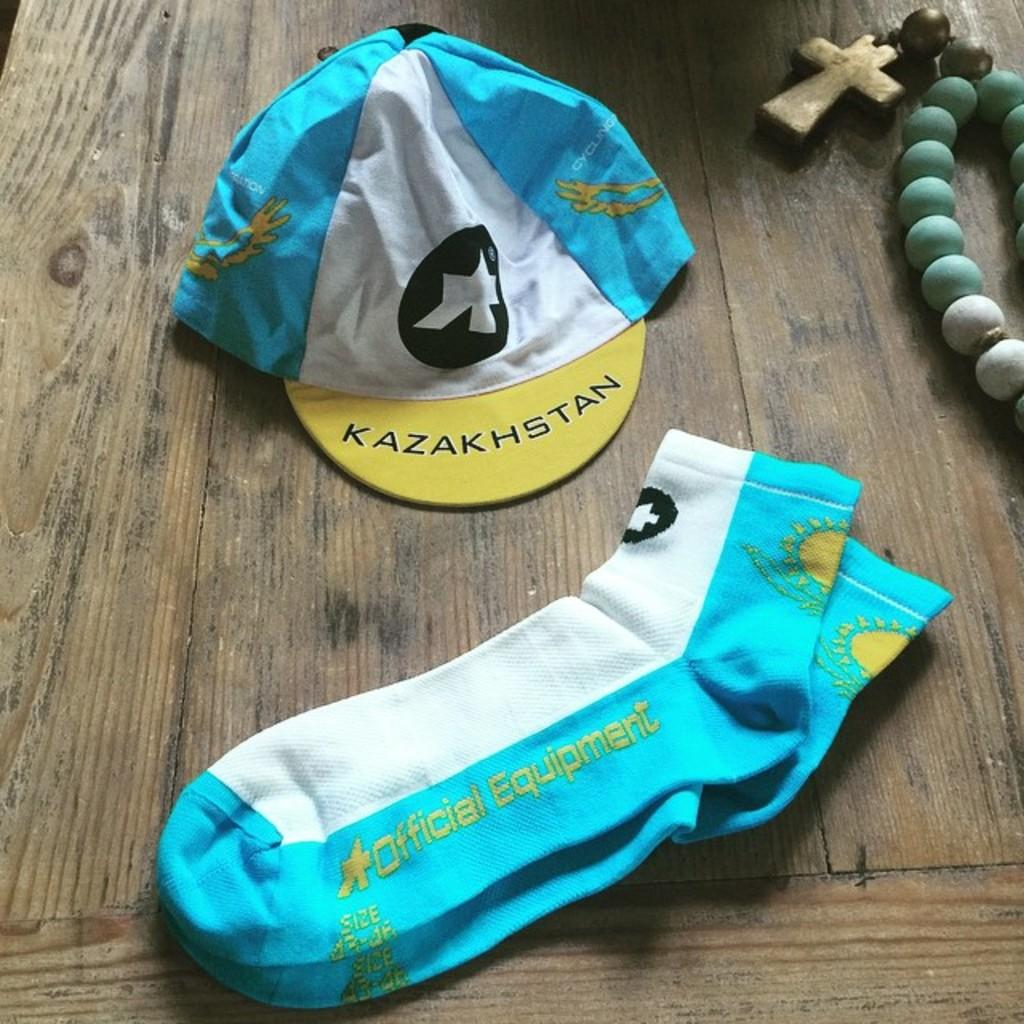What type of clothing items are on the table in the image? There are socks and a cap on the table in the image. What other object can be seen on the table? There is a chain on the table. What type of education is the girl receiving in the image? There is no girl present in the image, and therefore no education can be observed. 